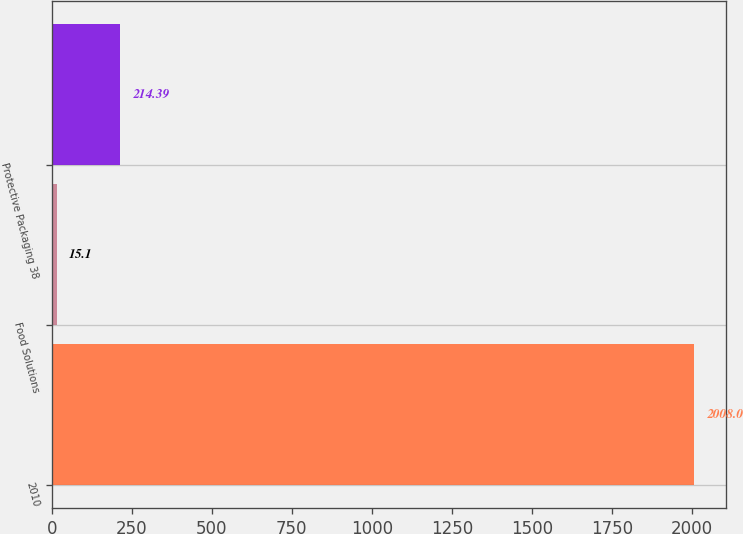<chart> <loc_0><loc_0><loc_500><loc_500><bar_chart><fcel>2010<fcel>Food Solutions<fcel>Protective Packaging 38<nl><fcel>2008<fcel>15.1<fcel>214.39<nl></chart> 